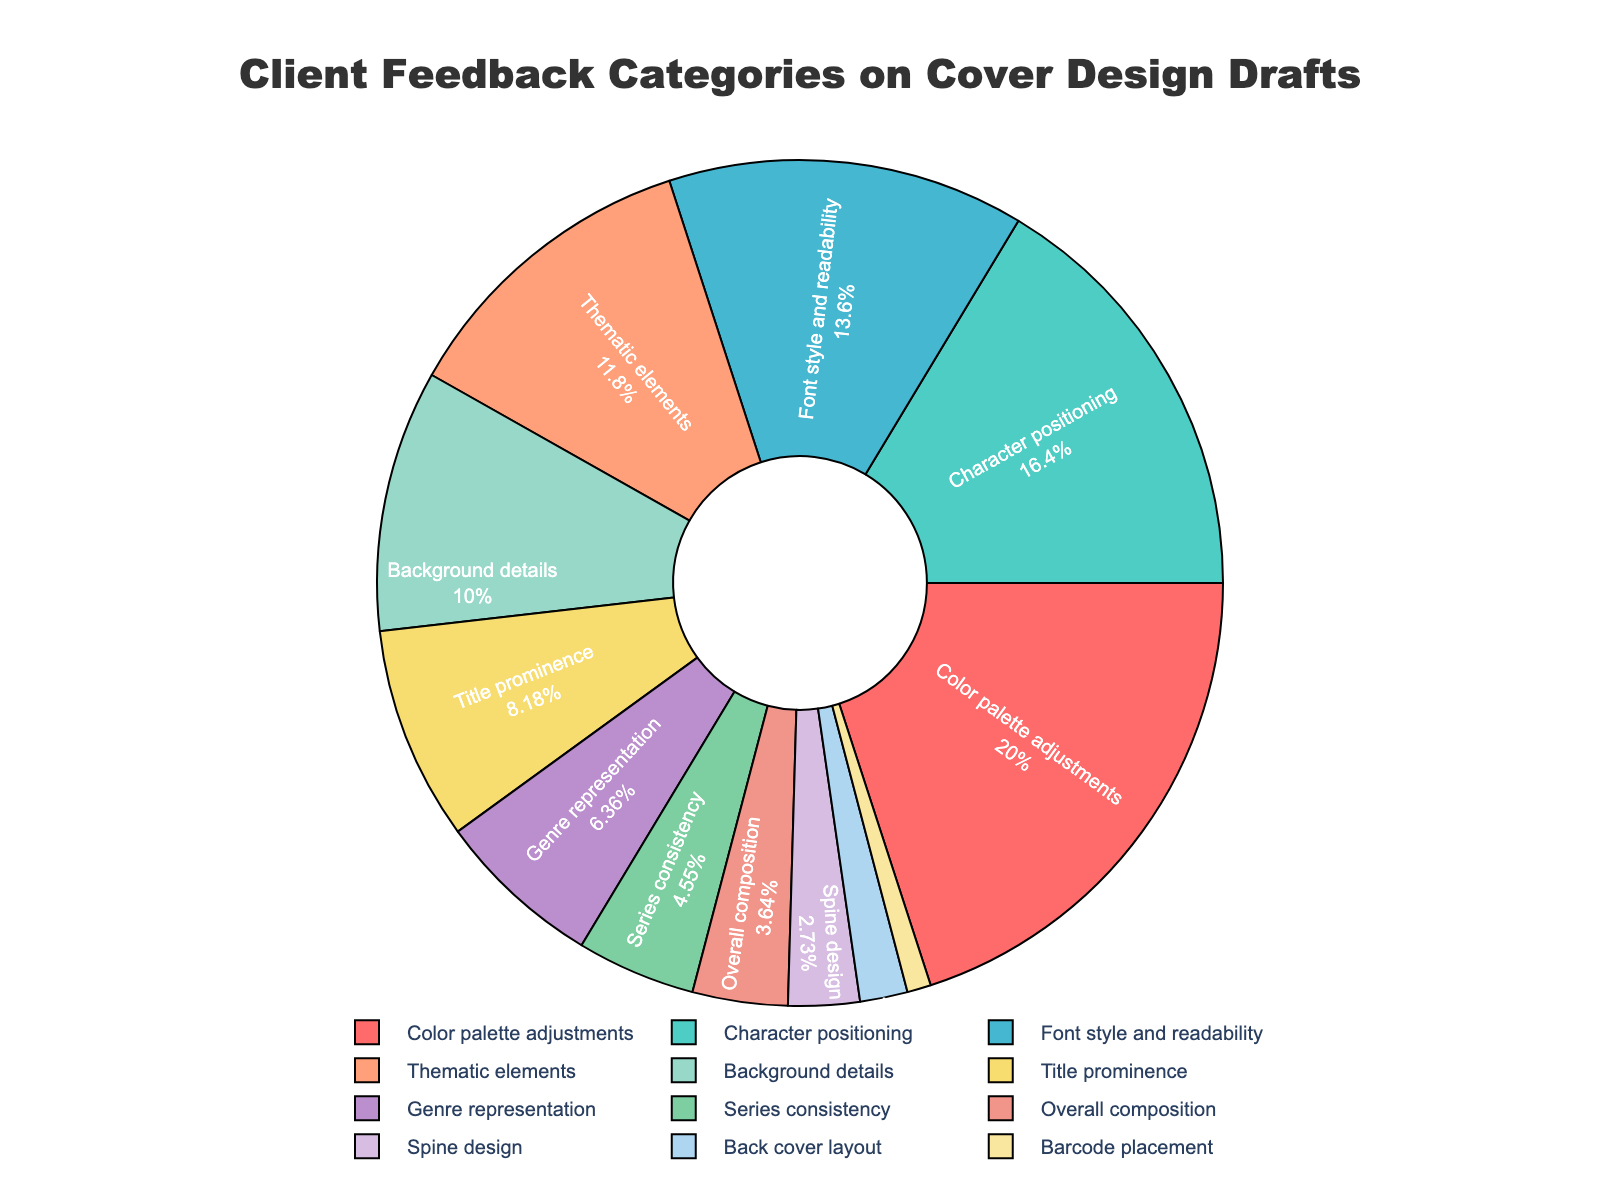Which feedback category received the highest percentage? The "Color palette adjustments" category has the highest percentage indicated at the top of the pie chart slice.
Answer: Color palette adjustments Which feedback category received the lowest percentage? The "Barcode placement" category has the lowest percentage, shown as the smallest slice in the pie chart.
Answer: Barcode placement What is the combined percentage of "Font style and readability" and "Title prominence"? Add the percentages of "Font style and readability" (15%) and "Title prominence" (9%) to get the combined percentage: 15% + 9% = 24%.
Answer: 24% How much greater is the percentage of "Character positioning" compared to "Background details"? Subtract the percentage of "Background details" (11%) from "Character positioning" (18%): 18% - 11% = 7%.
Answer: 7% Are there more comments about "Thematic elements" or "Series consistency"? Compare the percentages of "Thematic elements" (13%) and "Series consistency" (5%); "Thematic elements" has a higher percentage.
Answer: Thematic elements Which feedback categories make up less than 5% each? The categories with slices indicating less than 5% are "Overall composition" (4%), "Spine design" (3%), "Back cover layout" (2%), and "Barcode placement" (1%).
Answer: Overall composition, Spine design, Back cover layout, Barcode placement Calculate the total percentage of feedback related to "Background details", "Title prominence", and "Genre representation". Sum the percentages: "Background details" (11%), "Title prominence" (9%), and "Genre representation" (7%): 11% + 9% + 7% = 27%.
Answer: 27% How many feedback categories have a percentage of 10% or higher? Identify and count the categories with 10% or higher: "Color palette adjustments" (22%), "Character positioning" (18%), "Font style and readability" (15%), and "Thematic elements" (13%). There are 4 such categories.
Answer: 4 Which color is assigned to the "Character positioning" category in the pie chart? The color assigned to "Character positioning" can be identified visually in the pie chart; it appears as a teal-like color.
Answer: Teal 